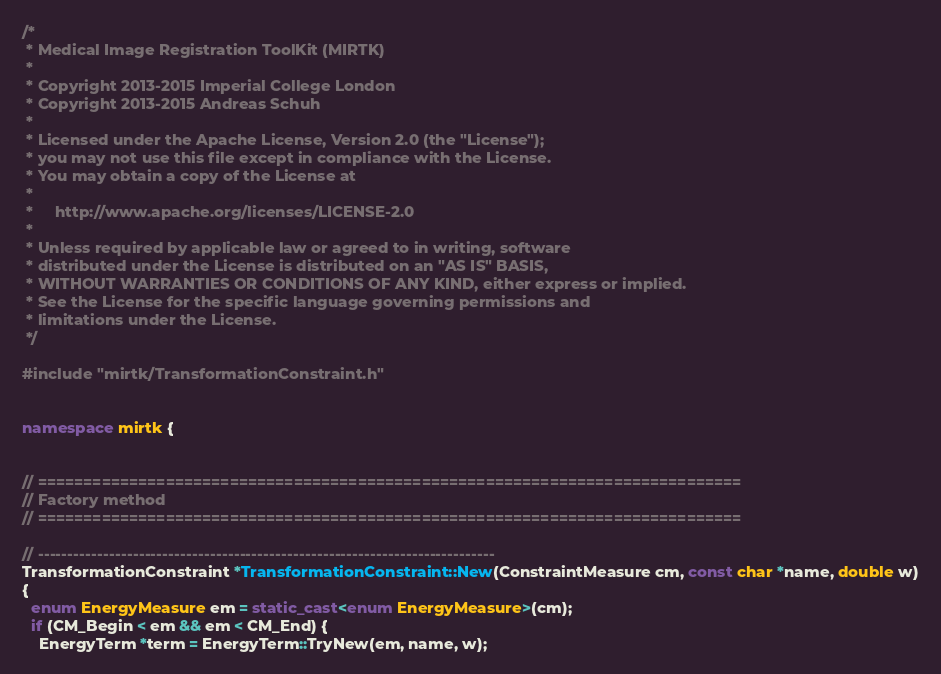<code> <loc_0><loc_0><loc_500><loc_500><_C++_>/*
 * Medical Image Registration ToolKit (MIRTK)
 *
 * Copyright 2013-2015 Imperial College London
 * Copyright 2013-2015 Andreas Schuh
 *
 * Licensed under the Apache License, Version 2.0 (the "License");
 * you may not use this file except in compliance with the License.
 * You may obtain a copy of the License at
 *
 *     http://www.apache.org/licenses/LICENSE-2.0
 *
 * Unless required by applicable law or agreed to in writing, software
 * distributed under the License is distributed on an "AS IS" BASIS,
 * WITHOUT WARRANTIES OR CONDITIONS OF ANY KIND, either express or implied.
 * See the License for the specific language governing permissions and
 * limitations under the License.
 */

#include "mirtk/TransformationConstraint.h"


namespace mirtk {


// =============================================================================
// Factory method
// =============================================================================

// -----------------------------------------------------------------------------
TransformationConstraint *TransformationConstraint::New(ConstraintMeasure cm, const char *name, double w)
{
  enum EnergyMeasure em = static_cast<enum EnergyMeasure>(cm);
  if (CM_Begin < em && em < CM_End) {
    EnergyTerm *term = EnergyTerm::TryNew(em, name, w);</code> 